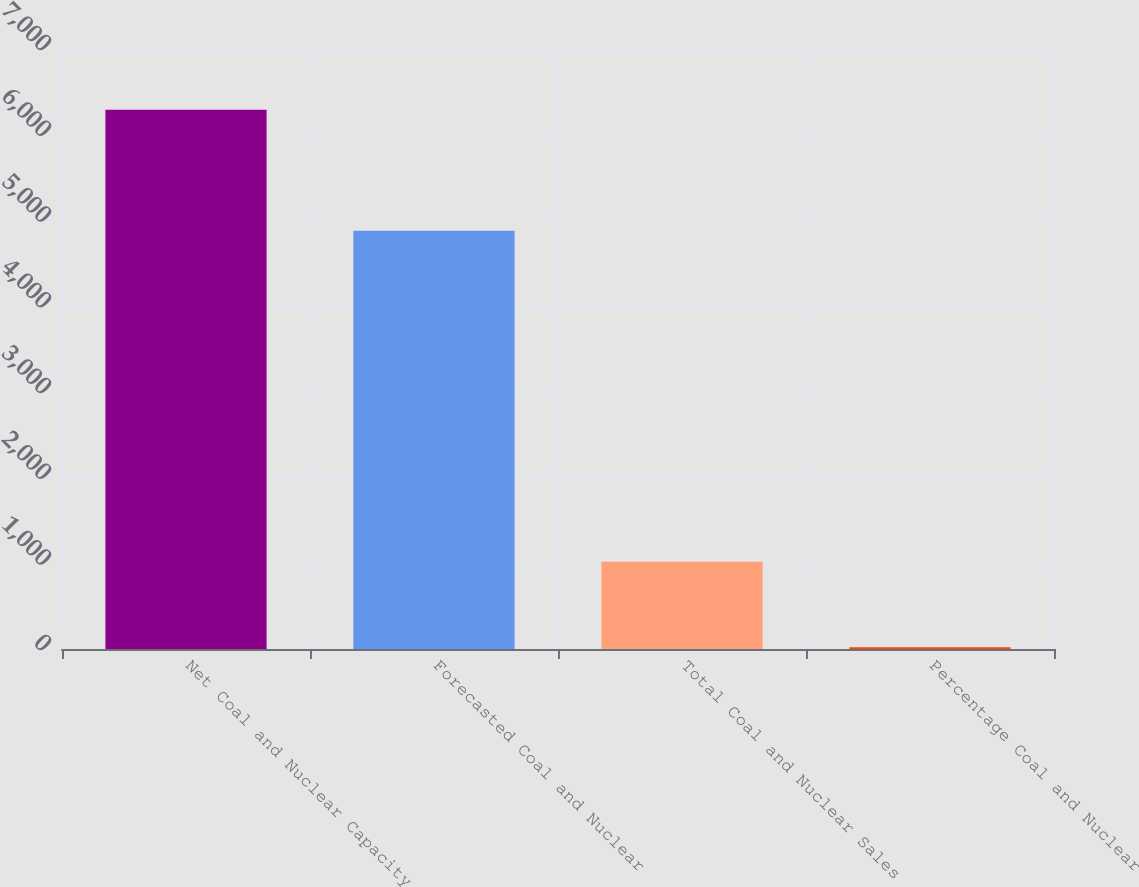Convert chart to OTSL. <chart><loc_0><loc_0><loc_500><loc_500><bar_chart><fcel>Net Coal and Nuclear Capacity<fcel>Forecasted Coal and Nuclear<fcel>Total Coal and Nuclear Sales<fcel>Percentage Coal and Nuclear<nl><fcel>6290<fcel>4881<fcel>1018<fcel>21<nl></chart> 